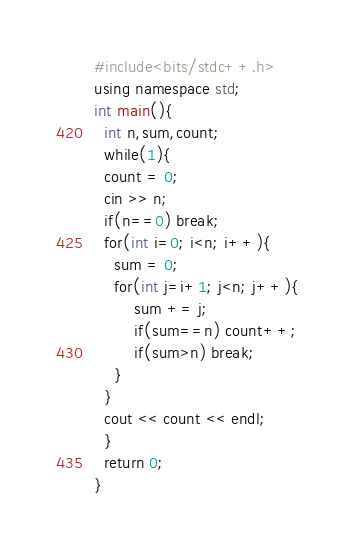<code> <loc_0><loc_0><loc_500><loc_500><_C++_>#include<bits/stdc++.h>
using namespace std;
int main(){
  int n,sum,count;
  while(1){
  count = 0;
  cin >> n;
  if(n==0) break;
  for(int i=0; i<n; i++){
    sum = 0;
    for(int j=i+1; j<n; j++){
        sum += j;
        if(sum==n) count++;
        if(sum>n) break;
    }
  }
  cout << count << endl;
  }
  return 0;
}
</code> 